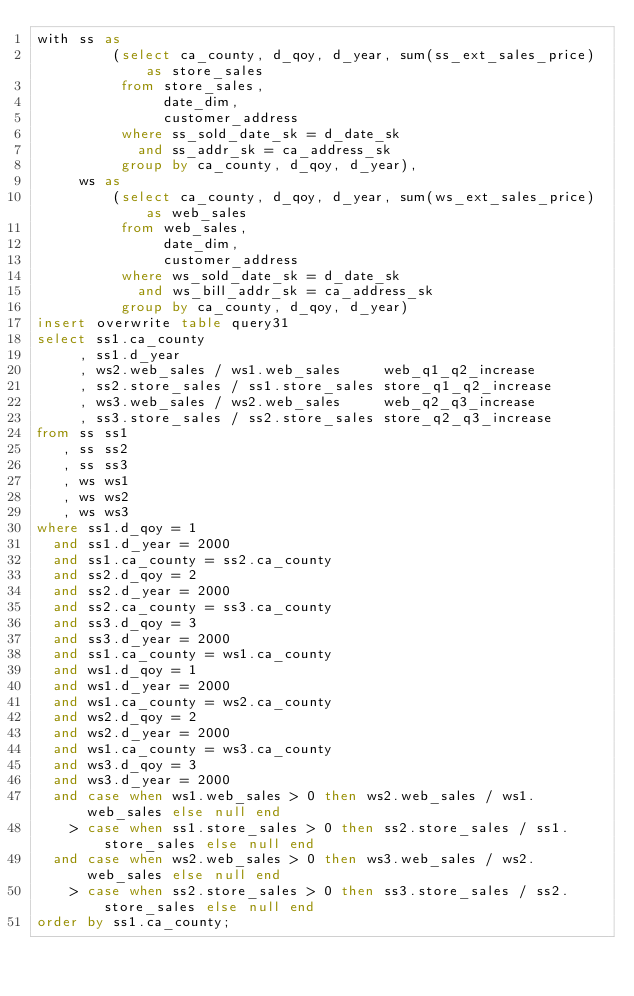<code> <loc_0><loc_0><loc_500><loc_500><_SQL_>with ss as
         (select ca_county, d_qoy, d_year, sum(ss_ext_sales_price) as store_sales
          from store_sales,
               date_dim,
               customer_address
          where ss_sold_date_sk = d_date_sk
            and ss_addr_sk = ca_address_sk
          group by ca_county, d_qoy, d_year),
     ws as
         (select ca_county, d_qoy, d_year, sum(ws_ext_sales_price) as web_sales
          from web_sales,
               date_dim,
               customer_address
          where ws_sold_date_sk = d_date_sk
            and ws_bill_addr_sk = ca_address_sk
          group by ca_county, d_qoy, d_year)
insert overwrite table query31
select ss1.ca_county
     , ss1.d_year
     , ws2.web_sales / ws1.web_sales     web_q1_q2_increase
     , ss2.store_sales / ss1.store_sales store_q1_q2_increase
     , ws3.web_sales / ws2.web_sales     web_q2_q3_increase
     , ss3.store_sales / ss2.store_sales store_q2_q3_increase
from ss ss1
   , ss ss2
   , ss ss3
   , ws ws1
   , ws ws2
   , ws ws3
where ss1.d_qoy = 1
  and ss1.d_year = 2000
  and ss1.ca_county = ss2.ca_county
  and ss2.d_qoy = 2
  and ss2.d_year = 2000
  and ss2.ca_county = ss3.ca_county
  and ss3.d_qoy = 3
  and ss3.d_year = 2000
  and ss1.ca_county = ws1.ca_county
  and ws1.d_qoy = 1
  and ws1.d_year = 2000
  and ws1.ca_county = ws2.ca_county
  and ws2.d_qoy = 2
  and ws2.d_year = 2000
  and ws1.ca_county = ws3.ca_county
  and ws3.d_qoy = 3
  and ws3.d_year = 2000
  and case when ws1.web_sales > 0 then ws2.web_sales / ws1.web_sales else null end
    > case when ss1.store_sales > 0 then ss2.store_sales / ss1.store_sales else null end
  and case when ws2.web_sales > 0 then ws3.web_sales / ws2.web_sales else null end
    > case when ss2.store_sales > 0 then ss3.store_sales / ss2.store_sales else null end
order by ss1.ca_county;
</code> 